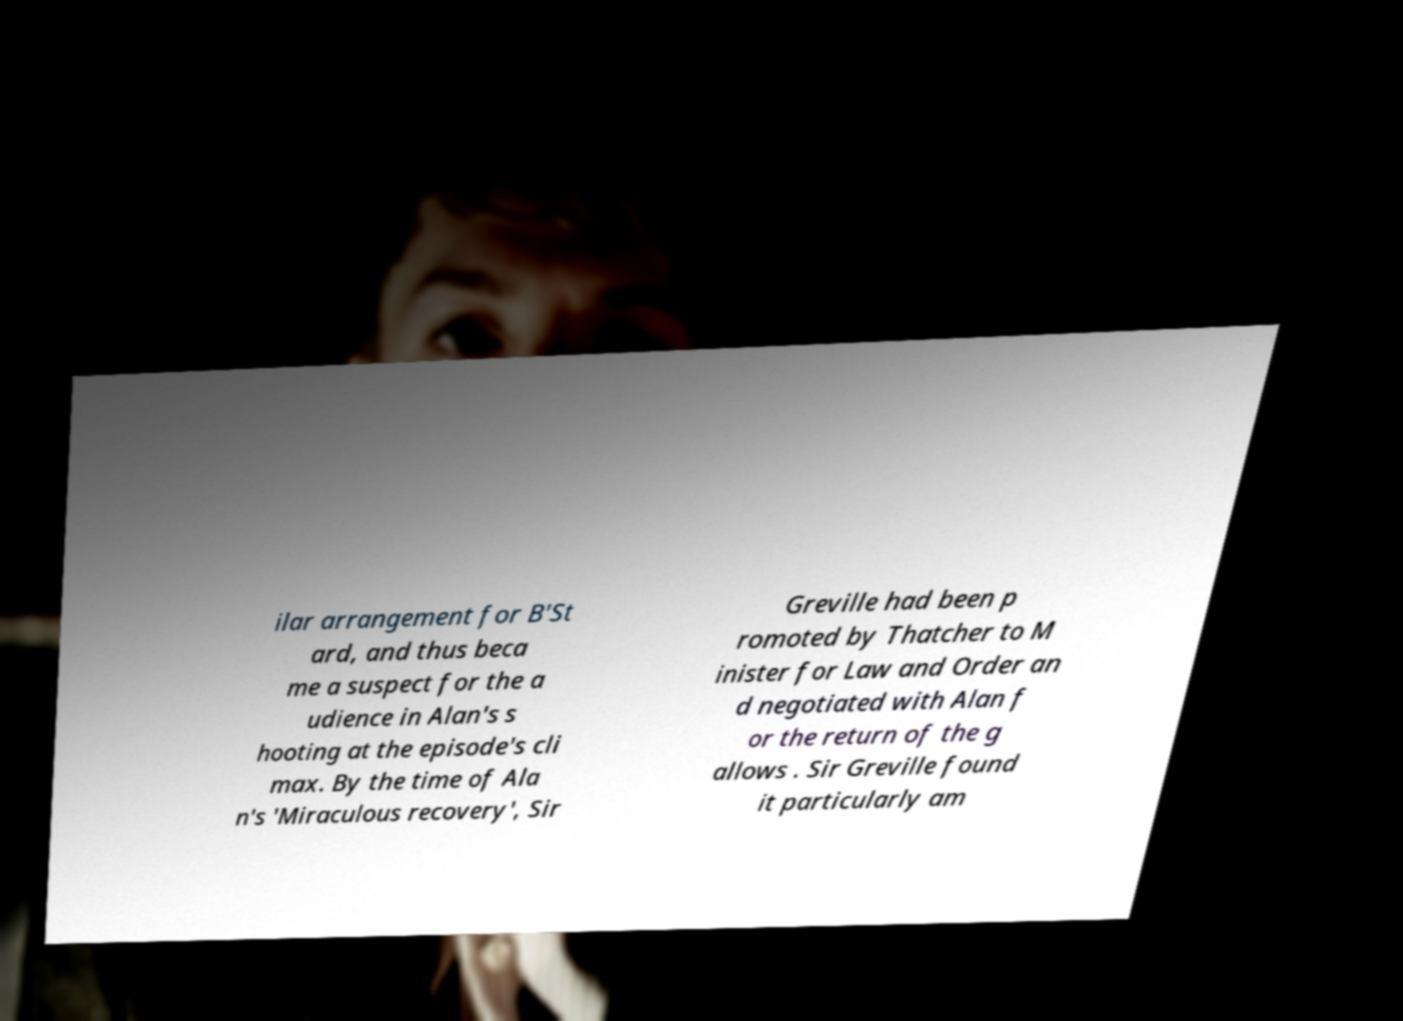I need the written content from this picture converted into text. Can you do that? ilar arrangement for B'St ard, and thus beca me a suspect for the a udience in Alan's s hooting at the episode's cli max. By the time of Ala n's 'Miraculous recovery', Sir Greville had been p romoted by Thatcher to M inister for Law and Order an d negotiated with Alan f or the return of the g allows . Sir Greville found it particularly am 